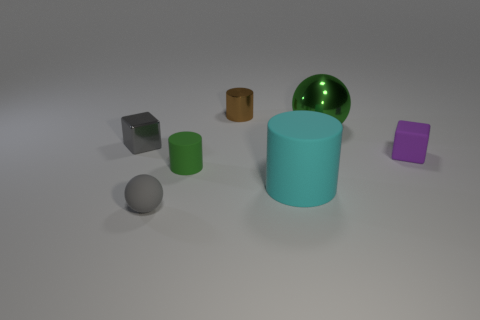Add 3 tiny cyan shiny cylinders. How many objects exist? 10 Subtract all cylinders. How many objects are left? 4 Subtract 0 green cubes. How many objects are left? 7 Subtract all purple cylinders. Subtract all green metal objects. How many objects are left? 6 Add 7 tiny spheres. How many tiny spheres are left? 8 Add 6 large brown rubber cylinders. How many large brown rubber cylinders exist? 6 